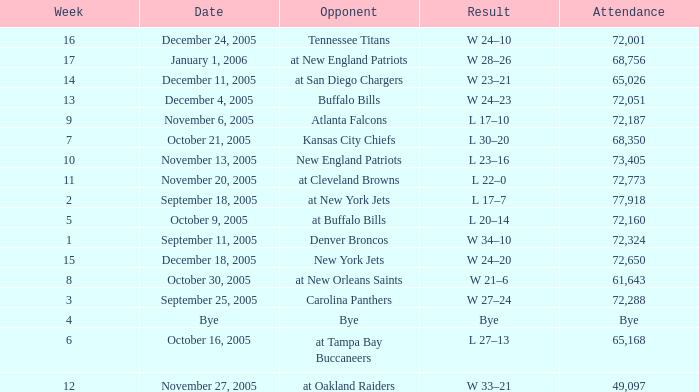In what Week was the Attendance 49,097? 12.0. 